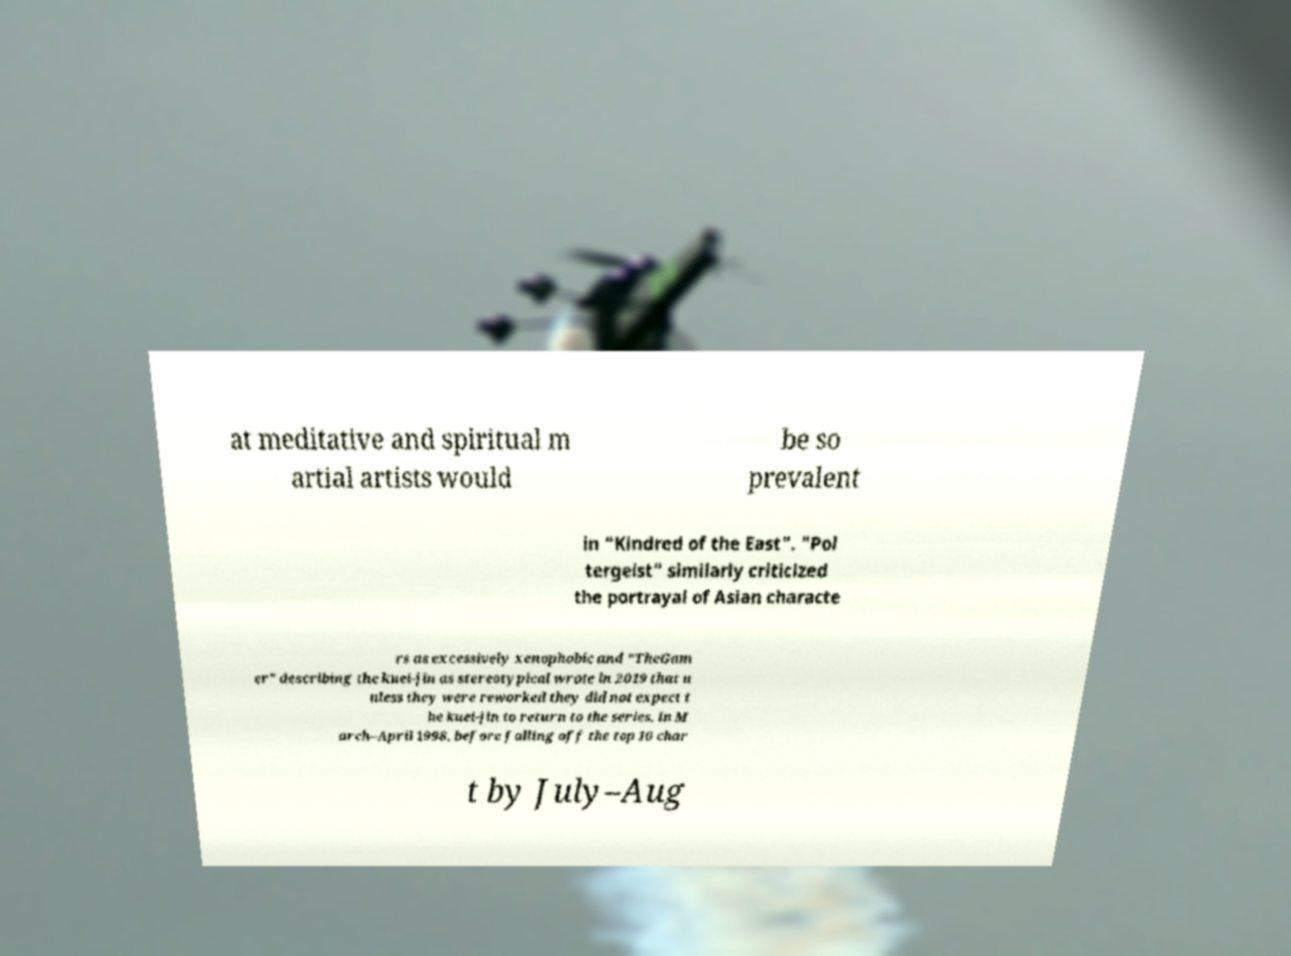Can you accurately transcribe the text from the provided image for me? at meditative and spiritual m artial artists would be so prevalent in "Kindred of the East". "Pol tergeist" similarly criticized the portrayal of Asian characte rs as excessively xenophobic and "TheGam er" describing the kuei-jin as stereotypical wrote in 2019 that u nless they were reworked they did not expect t he kuei-jin to return to the series. in M arch–April 1998, before falling off the top 10 char t by July–Aug 